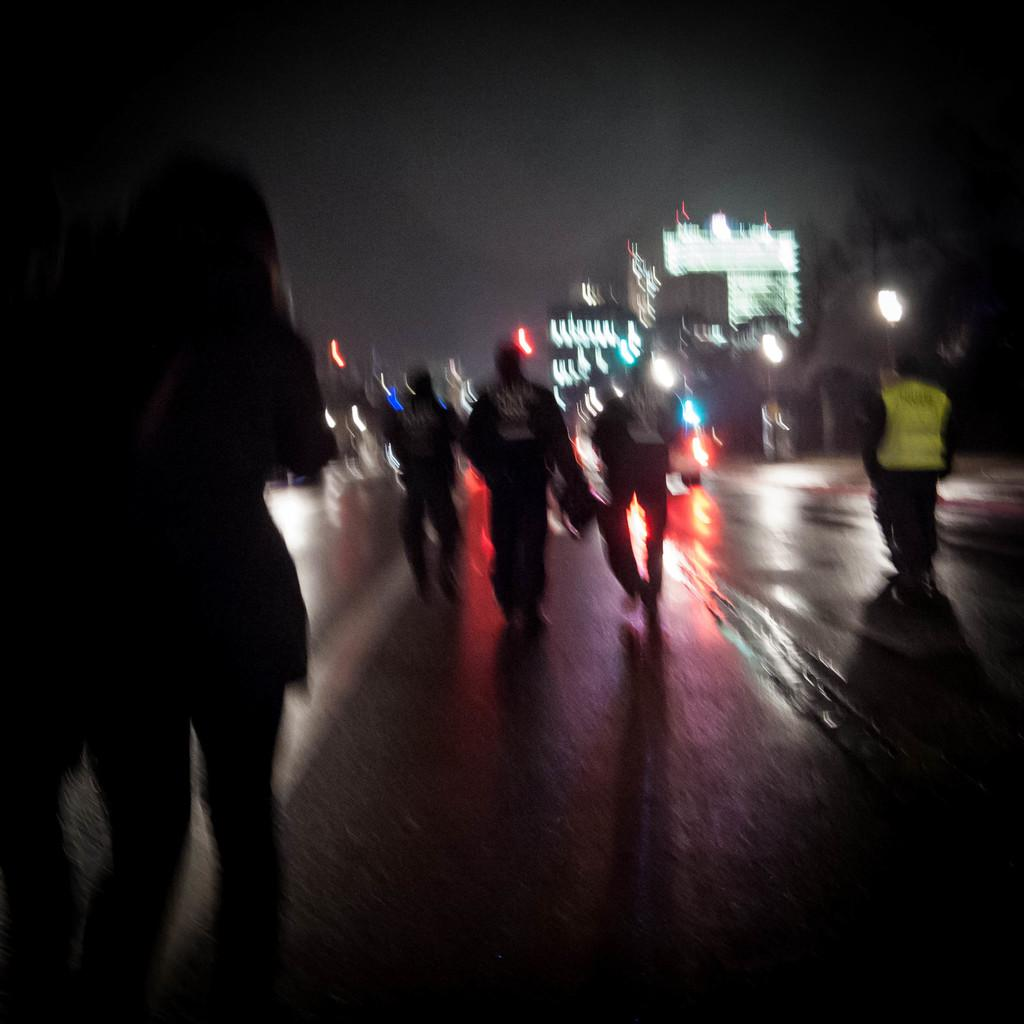What is happening with the group of people in the image? The people are walking on a road in the image. What can be seen in the background of the image? The background of the image is black. What structure is visible with lights in the image? There is a building with lights in the image. What type of apple is being used to look for oil in the image? There is no apple, looking for oil, or any reference to oil in the image. 